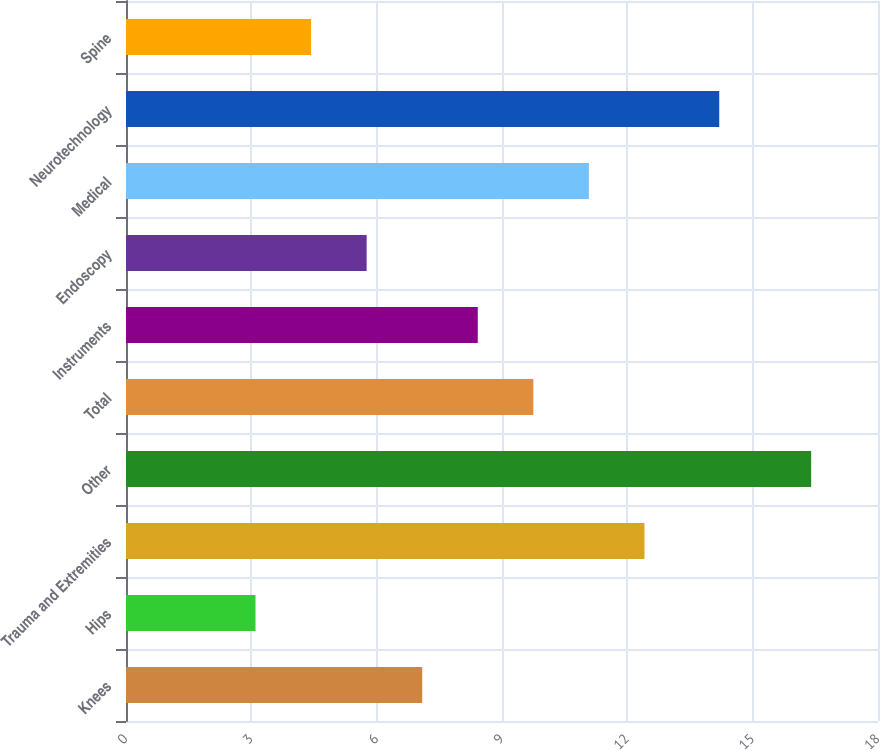Convert chart. <chart><loc_0><loc_0><loc_500><loc_500><bar_chart><fcel>Knees<fcel>Hips<fcel>Trauma and Extremities<fcel>Other<fcel>Total<fcel>Instruments<fcel>Endoscopy<fcel>Medical<fcel>Neurotechnology<fcel>Spine<nl><fcel>7.09<fcel>3.1<fcel>12.41<fcel>16.4<fcel>9.75<fcel>8.42<fcel>5.76<fcel>11.08<fcel>14.2<fcel>4.43<nl></chart> 